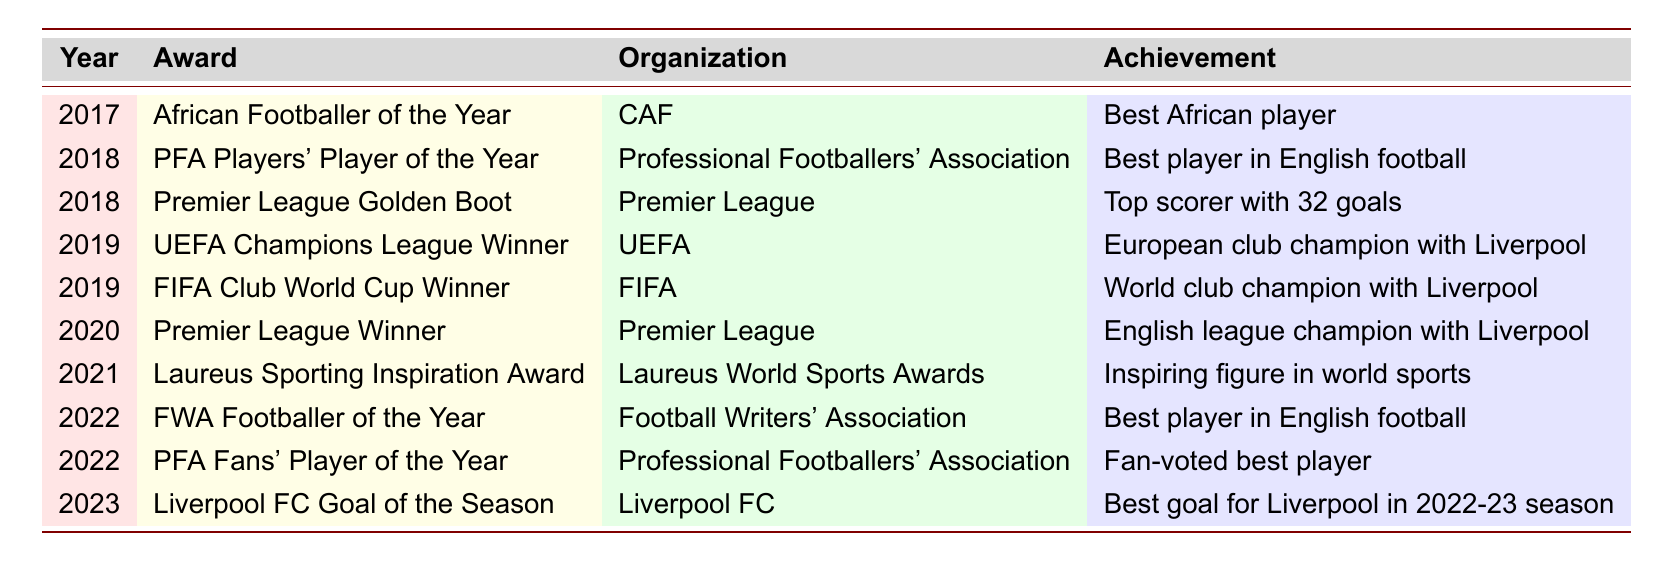What award did Mohamed Salah win in 2017? The table indicates that in 2017, Mohamed Salah won the "African Footballer of the Year" award from CAF.
Answer: African Footballer of the Year How many awards did Mohamed Salah receive in 2018? According to the table, Mohamed Salah received two awards in 2018: "PFA Players' Player of the Year" and "Premier League Golden Boot."
Answer: 2 Which organization awarded Mohamed Salah the Premier League Winner title? The table notes that the Premier League Winner title was awarded by the Premier League organization.
Answer: Premier League Did Mohamed Salah win the UEFA Champions League Winner award in 2020? The table shows that he won the UEFA Champions League Winner award in 2019, not 2020.
Answer: No What was Salah's achievement when he won the Premier League Golden Boot in 2018? The table lists that the achievement for the Premier League Golden Boot in 2018 was being the "Top scorer with 32 goals."
Answer: Top scorer with 32 goals In what year did Mohamed Salah win his first significant award? The first award listed in the table is in 2017, which was the African Footballer of the Year.
Answer: 2017 How many total awards has Mohamed Salah received according to the table? By counting the awards listed in the table, there are ten awards total.
Answer: 10 What is the significance of the Laureus Sporting Inspiration Award won by Salah? The table describes the significance as being an "Inspiring figure in world sports," which shows his influence beyond just football.
Answer: Inspiring figure in world sports Which award did Mohamed Salah receive in 2022 that was fan-voted? The PFA Fans' Player of the Year award, awarded in 2022, was specifically noted as fan-voted in the table.
Answer: PFA Fans' Player of the Year Compare the number of awards received in 2021 and 2022. In 2021, Mohamed Salah won one award (Laureus Sporting Inspiration Award), and in 2022, he won two awards (FWA Footballer of the Year and PFA Fans' Player of the Year), making a difference of one more award in 2022.
Answer: 1 more award in 2022 